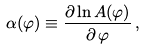<formula> <loc_0><loc_0><loc_500><loc_500>\alpha ( \varphi ) \equiv \frac { \partial \ln A ( \varphi ) } { \partial \, \varphi } \, ,</formula> 